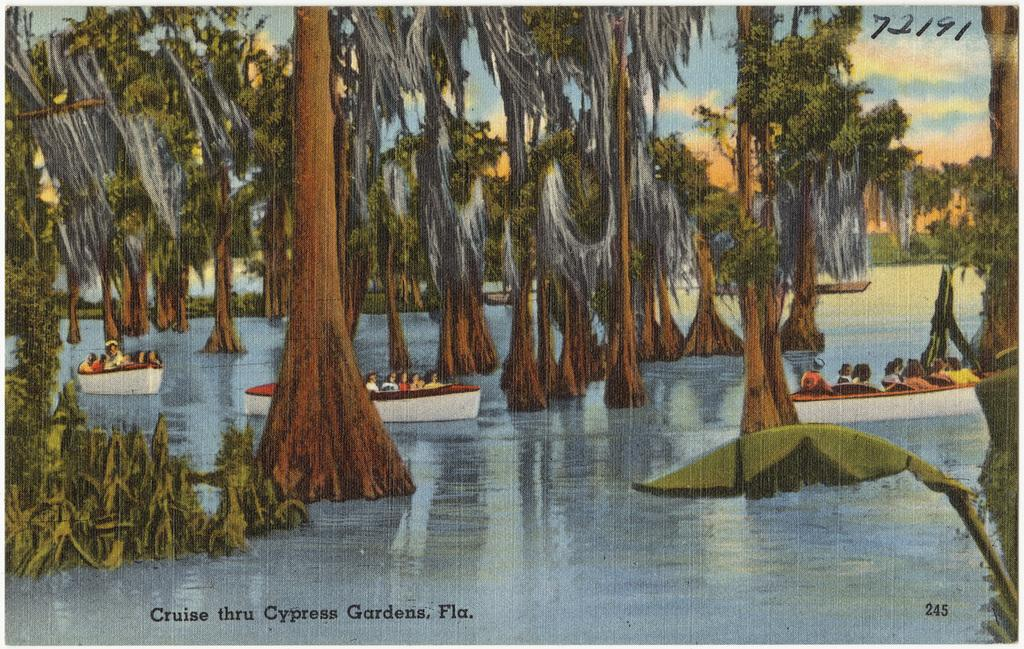What is the main subject of the poster in the image? The poster contains people in boats. What other elements are present in the poster? The poster depicts trees, water, and the sky. Is there any text on the poster? Yes, there is text on the poster. Are there any numbers on the poster? Yes, there are numbers on the poster. Can you tell me how many ladybugs are on the poster? There are no ladybugs present on the poster; it features people in boats, trees, water, the sky, text, and numbers. 